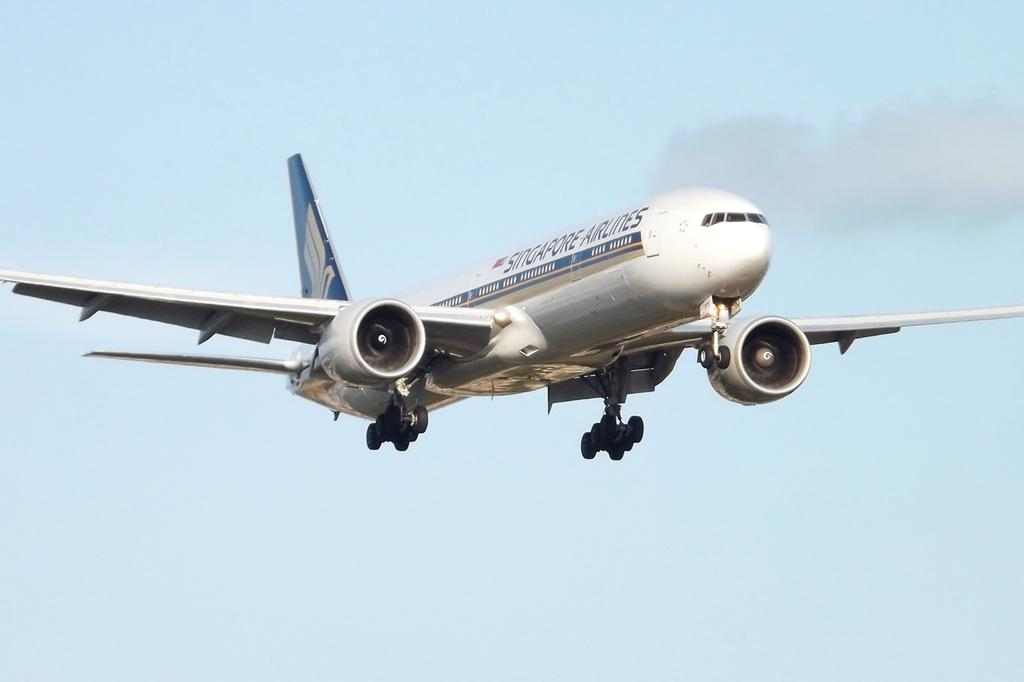What is the main subject of the image? The main subject of the image is an airplane. Where is the airplane located in the image? The airplane is in the sky. How many flowers are hanging from the airplane's wings in the image? There are no flowers present in the image, as it features an airplane in the sky. 